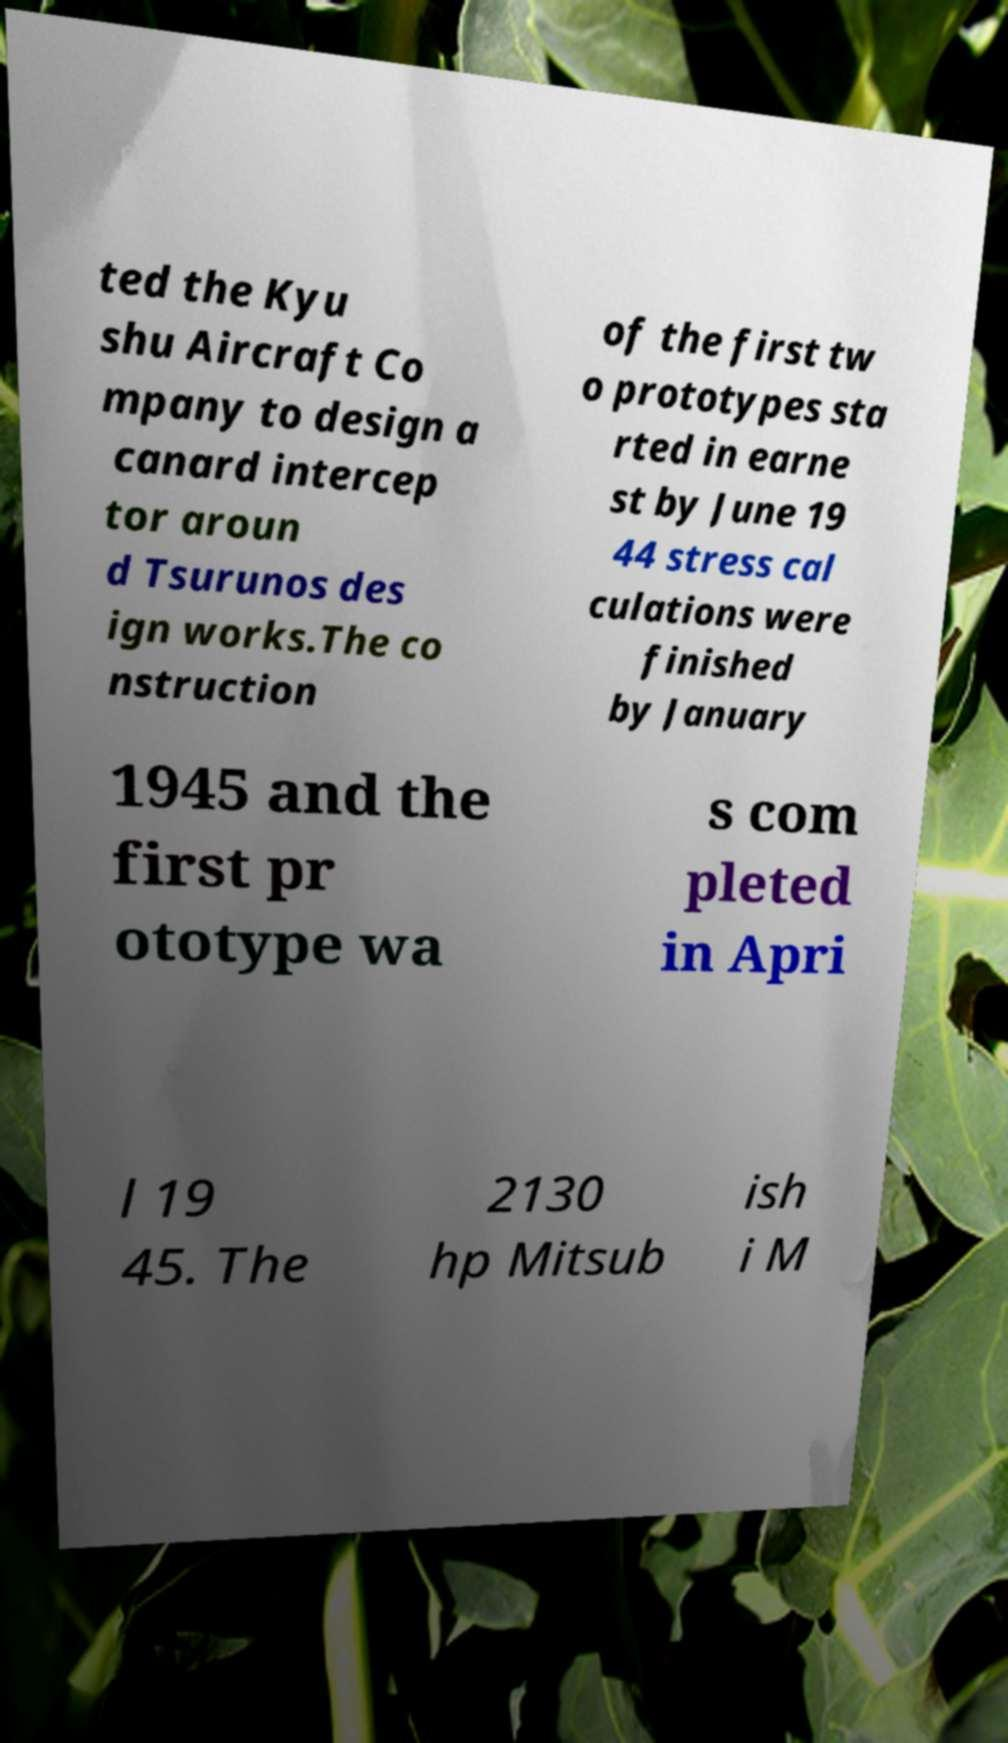Could you assist in decoding the text presented in this image and type it out clearly? ted the Kyu shu Aircraft Co mpany to design a canard intercep tor aroun d Tsurunos des ign works.The co nstruction of the first tw o prototypes sta rted in earne st by June 19 44 stress cal culations were finished by January 1945 and the first pr ototype wa s com pleted in Apri l 19 45. The 2130 hp Mitsub ish i M 